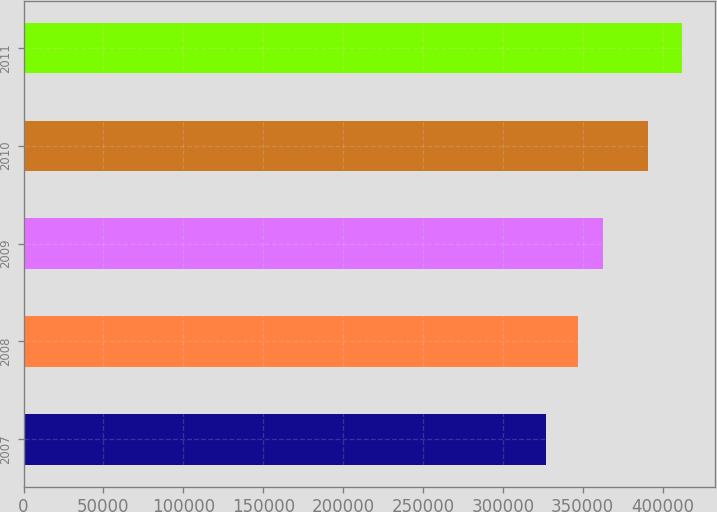Convert chart to OTSL. <chart><loc_0><loc_0><loc_500><loc_500><bar_chart><fcel>2007<fcel>2008<fcel>2009<fcel>2010<fcel>2011<nl><fcel>327000<fcel>347000<fcel>363000<fcel>391000<fcel>412000<nl></chart> 